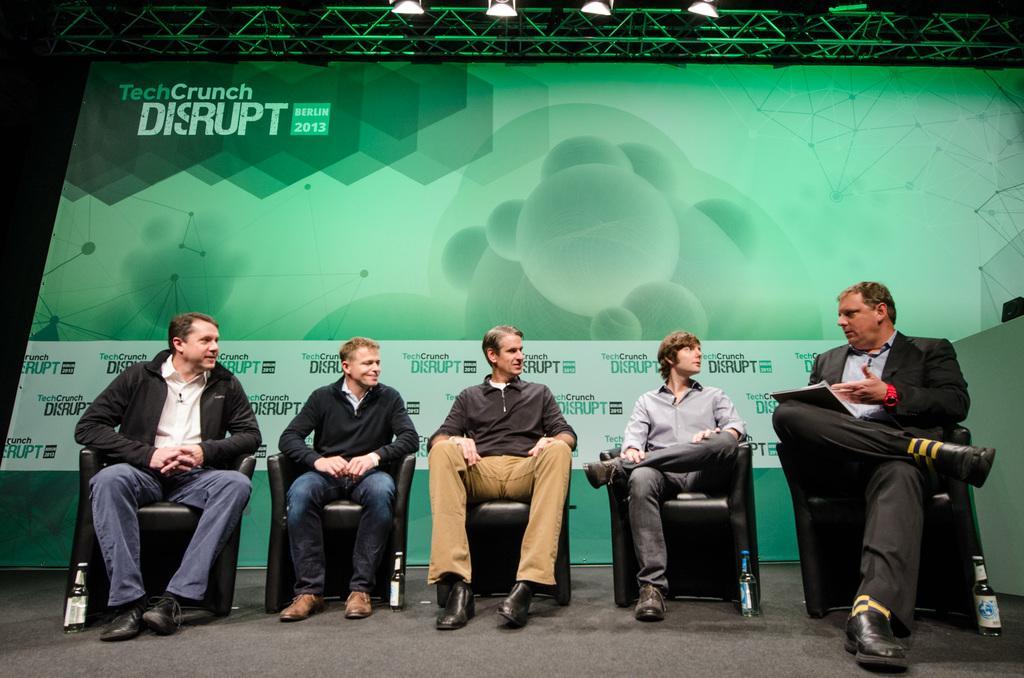Could you give a brief overview of what you see in this image? In this image we can see people sitting. At the bottom there are bottles placed on the floor. The man sitting on the right is holding a book. In the background there is a board. At the top there are lights. 